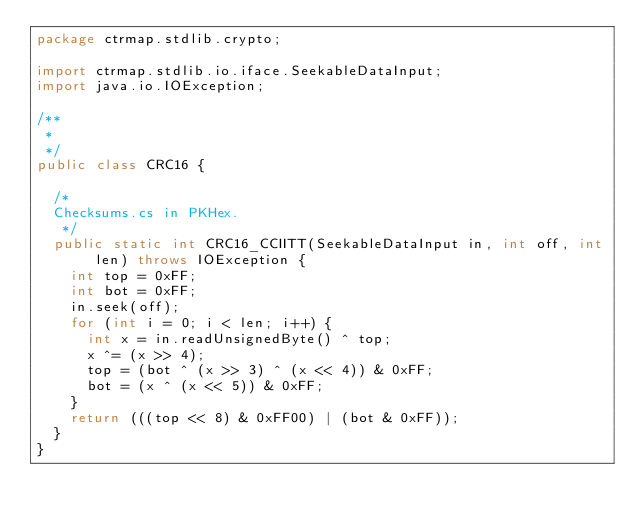Convert code to text. <code><loc_0><loc_0><loc_500><loc_500><_Java_>package ctrmap.stdlib.crypto;

import ctrmap.stdlib.io.iface.SeekableDataInput;
import java.io.IOException;

/**
 *
 */
public class CRC16 {

	/*
	Checksums.cs in PKHex.
	 */
	public static int CRC16_CCIITT(SeekableDataInput in, int off, int len) throws IOException {
		int top = 0xFF;
		int bot = 0xFF;
		in.seek(off);
		for (int i = 0; i < len; i++) {
			int x = in.readUnsignedByte() ^ top;
			x ^= (x >> 4);
			top = (bot ^ (x >> 3) ^ (x << 4)) & 0xFF;
			bot = (x ^ (x << 5)) & 0xFF;
		}
		return (((top << 8) & 0xFF00) | (bot & 0xFF));
	}
}
</code> 